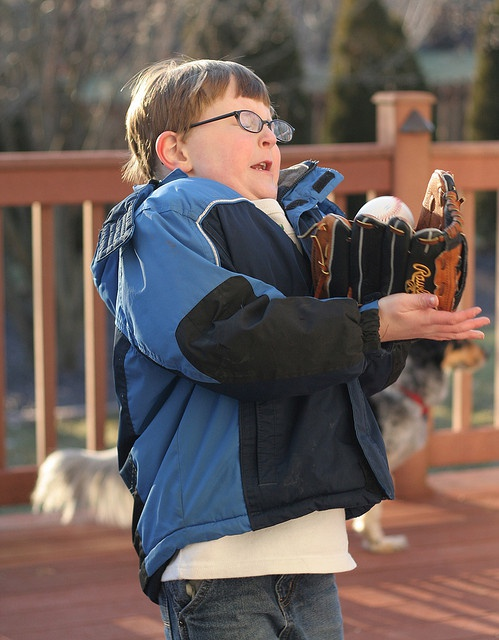Describe the objects in this image and their specific colors. I can see people in gray, black, and blue tones, baseball glove in gray, black, maroon, and brown tones, dog in gray and black tones, dog in gray, darkgray, tan, and beige tones, and sports ball in gray, lightgray, pink, tan, and darkgray tones in this image. 